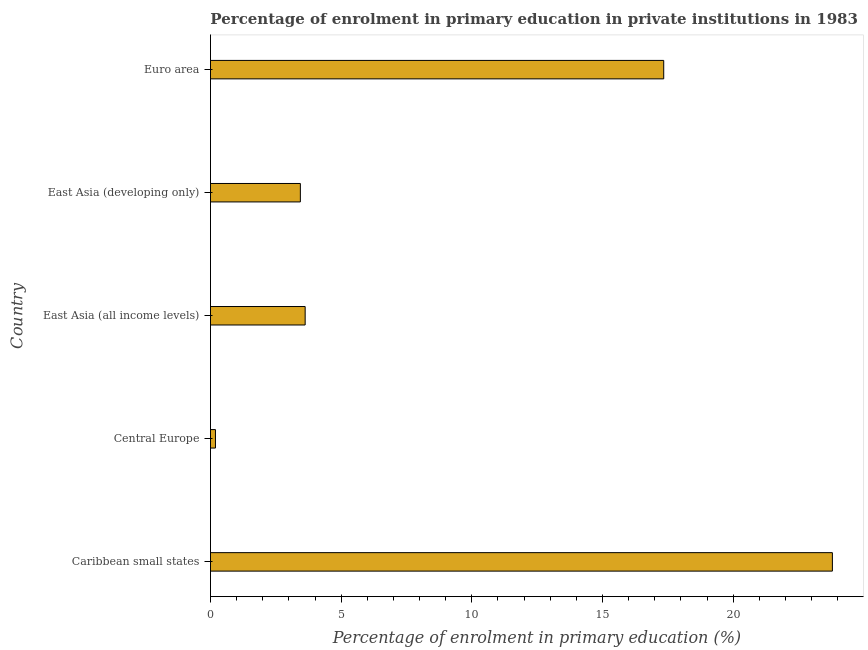Does the graph contain grids?
Your answer should be very brief. No. What is the title of the graph?
Your answer should be compact. Percentage of enrolment in primary education in private institutions in 1983. What is the label or title of the X-axis?
Offer a terse response. Percentage of enrolment in primary education (%). What is the enrolment percentage in primary education in East Asia (developing only)?
Offer a very short reply. 3.44. Across all countries, what is the maximum enrolment percentage in primary education?
Provide a succinct answer. 23.8. Across all countries, what is the minimum enrolment percentage in primary education?
Offer a very short reply. 0.19. In which country was the enrolment percentage in primary education maximum?
Ensure brevity in your answer.  Caribbean small states. In which country was the enrolment percentage in primary education minimum?
Offer a very short reply. Central Europe. What is the sum of the enrolment percentage in primary education?
Provide a short and direct response. 48.39. What is the difference between the enrolment percentage in primary education in East Asia (all income levels) and Euro area?
Make the answer very short. -13.72. What is the average enrolment percentage in primary education per country?
Your answer should be very brief. 9.68. What is the median enrolment percentage in primary education?
Keep it short and to the point. 3.62. In how many countries, is the enrolment percentage in primary education greater than 11 %?
Your answer should be very brief. 2. What is the ratio of the enrolment percentage in primary education in Central Europe to that in Euro area?
Keep it short and to the point. 0.01. Is the enrolment percentage in primary education in Caribbean small states less than that in East Asia (developing only)?
Give a very brief answer. No. Is the difference between the enrolment percentage in primary education in Caribbean small states and Central Europe greater than the difference between any two countries?
Provide a succinct answer. Yes. What is the difference between the highest and the second highest enrolment percentage in primary education?
Your answer should be compact. 6.45. What is the difference between the highest and the lowest enrolment percentage in primary education?
Give a very brief answer. 23.6. In how many countries, is the enrolment percentage in primary education greater than the average enrolment percentage in primary education taken over all countries?
Provide a short and direct response. 2. Are the values on the major ticks of X-axis written in scientific E-notation?
Offer a very short reply. No. What is the Percentage of enrolment in primary education (%) of Caribbean small states?
Your answer should be very brief. 23.8. What is the Percentage of enrolment in primary education (%) in Central Europe?
Ensure brevity in your answer.  0.19. What is the Percentage of enrolment in primary education (%) of East Asia (all income levels)?
Give a very brief answer. 3.62. What is the Percentage of enrolment in primary education (%) of East Asia (developing only)?
Your answer should be compact. 3.44. What is the Percentage of enrolment in primary education (%) of Euro area?
Make the answer very short. 17.34. What is the difference between the Percentage of enrolment in primary education (%) in Caribbean small states and Central Europe?
Your answer should be very brief. 23.6. What is the difference between the Percentage of enrolment in primary education (%) in Caribbean small states and East Asia (all income levels)?
Keep it short and to the point. 20.17. What is the difference between the Percentage of enrolment in primary education (%) in Caribbean small states and East Asia (developing only)?
Make the answer very short. 20.36. What is the difference between the Percentage of enrolment in primary education (%) in Caribbean small states and Euro area?
Give a very brief answer. 6.45. What is the difference between the Percentage of enrolment in primary education (%) in Central Europe and East Asia (all income levels)?
Provide a succinct answer. -3.43. What is the difference between the Percentage of enrolment in primary education (%) in Central Europe and East Asia (developing only)?
Ensure brevity in your answer.  -3.25. What is the difference between the Percentage of enrolment in primary education (%) in Central Europe and Euro area?
Your answer should be very brief. -17.15. What is the difference between the Percentage of enrolment in primary education (%) in East Asia (all income levels) and East Asia (developing only)?
Your answer should be very brief. 0.18. What is the difference between the Percentage of enrolment in primary education (%) in East Asia (all income levels) and Euro area?
Offer a very short reply. -13.72. What is the difference between the Percentage of enrolment in primary education (%) in East Asia (developing only) and Euro area?
Offer a very short reply. -13.9. What is the ratio of the Percentage of enrolment in primary education (%) in Caribbean small states to that in Central Europe?
Your response must be concise. 124.51. What is the ratio of the Percentage of enrolment in primary education (%) in Caribbean small states to that in East Asia (all income levels)?
Make the answer very short. 6.57. What is the ratio of the Percentage of enrolment in primary education (%) in Caribbean small states to that in East Asia (developing only)?
Give a very brief answer. 6.92. What is the ratio of the Percentage of enrolment in primary education (%) in Caribbean small states to that in Euro area?
Your response must be concise. 1.37. What is the ratio of the Percentage of enrolment in primary education (%) in Central Europe to that in East Asia (all income levels)?
Your answer should be very brief. 0.05. What is the ratio of the Percentage of enrolment in primary education (%) in Central Europe to that in East Asia (developing only)?
Give a very brief answer. 0.06. What is the ratio of the Percentage of enrolment in primary education (%) in Central Europe to that in Euro area?
Provide a succinct answer. 0.01. What is the ratio of the Percentage of enrolment in primary education (%) in East Asia (all income levels) to that in East Asia (developing only)?
Give a very brief answer. 1.05. What is the ratio of the Percentage of enrolment in primary education (%) in East Asia (all income levels) to that in Euro area?
Offer a terse response. 0.21. What is the ratio of the Percentage of enrolment in primary education (%) in East Asia (developing only) to that in Euro area?
Offer a terse response. 0.2. 